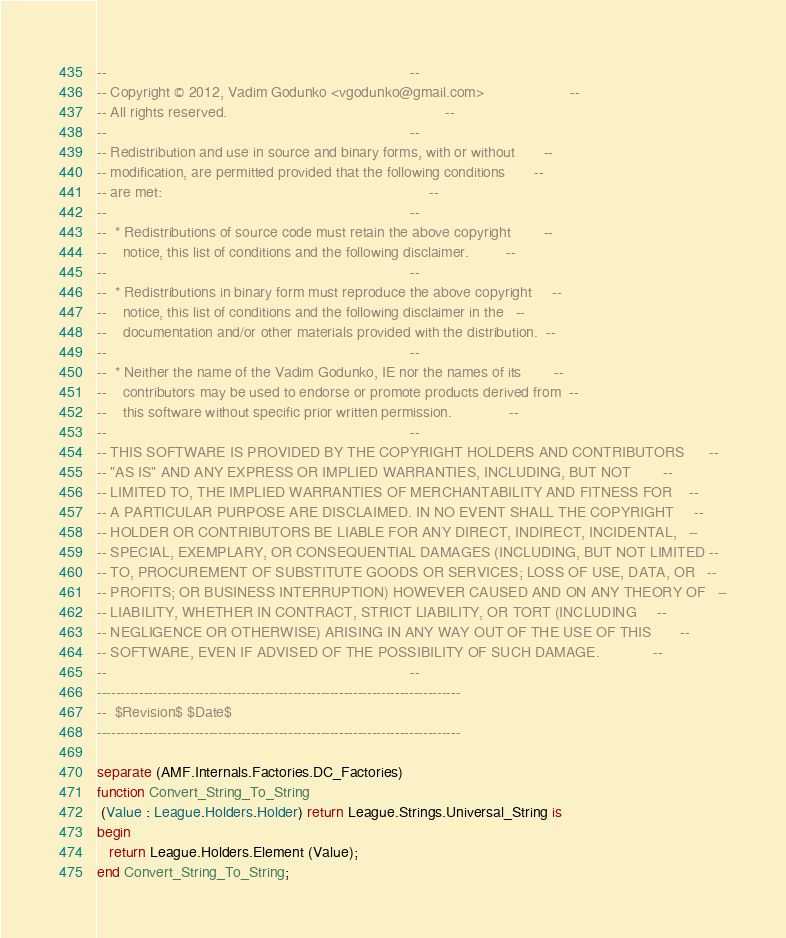<code> <loc_0><loc_0><loc_500><loc_500><_Ada_>--                                                                          --
-- Copyright © 2012, Vadim Godunko <vgodunko@gmail.com>                     --
-- All rights reserved.                                                     --
--                                                                          --
-- Redistribution and use in source and binary forms, with or without       --
-- modification, are permitted provided that the following conditions       --
-- are met:                                                                 --
--                                                                          --
--  * Redistributions of source code must retain the above copyright        --
--    notice, this list of conditions and the following disclaimer.         --
--                                                                          --
--  * Redistributions in binary form must reproduce the above copyright     --
--    notice, this list of conditions and the following disclaimer in the   --
--    documentation and/or other materials provided with the distribution.  --
--                                                                          --
--  * Neither the name of the Vadim Godunko, IE nor the names of its        --
--    contributors may be used to endorse or promote products derived from  --
--    this software without specific prior written permission.              --
--                                                                          --
-- THIS SOFTWARE IS PROVIDED BY THE COPYRIGHT HOLDERS AND CONTRIBUTORS      --
-- "AS IS" AND ANY EXPRESS OR IMPLIED WARRANTIES, INCLUDING, BUT NOT        --
-- LIMITED TO, THE IMPLIED WARRANTIES OF MERCHANTABILITY AND FITNESS FOR    --
-- A PARTICULAR PURPOSE ARE DISCLAIMED. IN NO EVENT SHALL THE COPYRIGHT     --
-- HOLDER OR CONTRIBUTORS BE LIABLE FOR ANY DIRECT, INDIRECT, INCIDENTAL,   --
-- SPECIAL, EXEMPLARY, OR CONSEQUENTIAL DAMAGES (INCLUDING, BUT NOT LIMITED --
-- TO, PROCUREMENT OF SUBSTITUTE GOODS OR SERVICES; LOSS OF USE, DATA, OR   --
-- PROFITS; OR BUSINESS INTERRUPTION) HOWEVER CAUSED AND ON ANY THEORY OF   --
-- LIABILITY, WHETHER IN CONTRACT, STRICT LIABILITY, OR TORT (INCLUDING     --
-- NEGLIGENCE OR OTHERWISE) ARISING IN ANY WAY OUT OF THE USE OF THIS       --
-- SOFTWARE, EVEN IF ADVISED OF THE POSSIBILITY OF SUCH DAMAGE.             --
--                                                                          --
------------------------------------------------------------------------------
--  $Revision$ $Date$
------------------------------------------------------------------------------

separate (AMF.Internals.Factories.DC_Factories)
function Convert_String_To_String
 (Value : League.Holders.Holder) return League.Strings.Universal_String is
begin
   return League.Holders.Element (Value);
end Convert_String_To_String;
</code> 